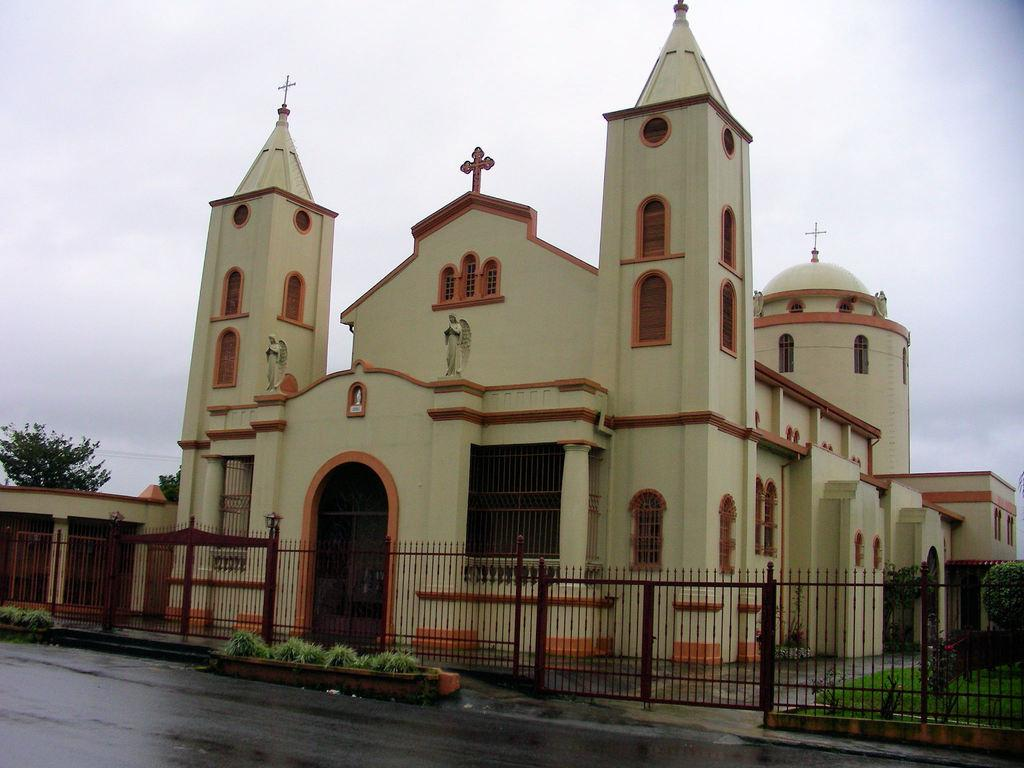What type of surface can be seen in the image? There is a road in the image. What type of vegetation is present in the image? There is grass, plants, and trees in the image. What type of architectural feature can be seen in the image? There is a gate and a church in the image. What type of material is used for the grills in the image? There are iron grills in the image. What part of the natural environment is visible in the image? The sky is visible in the image. What time of day is it in the image, and can you see a crook interacting with a frog? The time of day is not mentioned in the image, and there is no crook or frog present in the image. 